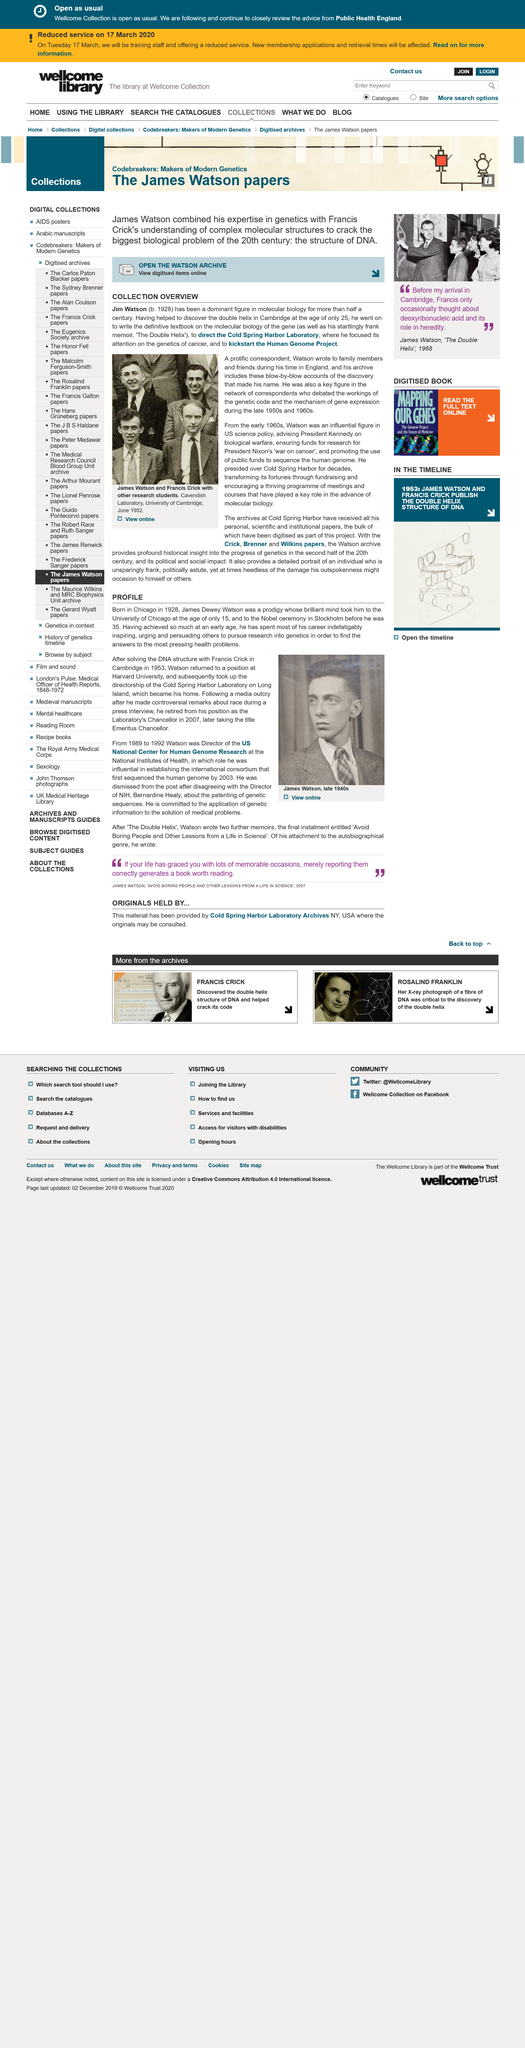Indicate a few pertinent items in this graphic. The person depicted in the photograph is James Dewey Watson. James Dewey Watson, born in Chicago, is known for his contributions to the field of molecular biology and genetics. At the age of 15, James Dewey Watson studied at the University of Chicago. 